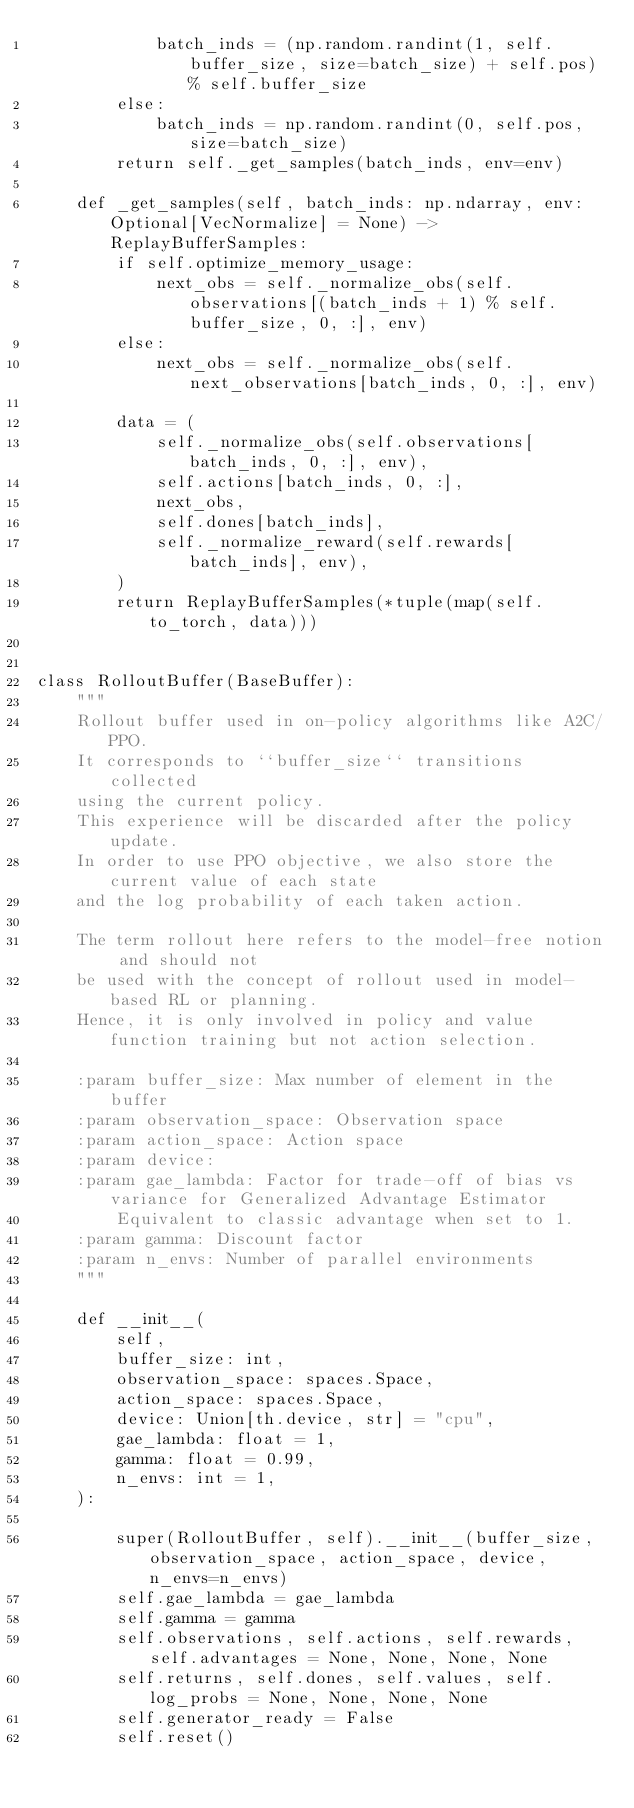<code> <loc_0><loc_0><loc_500><loc_500><_Python_>            batch_inds = (np.random.randint(1, self.buffer_size, size=batch_size) + self.pos) % self.buffer_size
        else:
            batch_inds = np.random.randint(0, self.pos, size=batch_size)
        return self._get_samples(batch_inds, env=env)

    def _get_samples(self, batch_inds: np.ndarray, env: Optional[VecNormalize] = None) -> ReplayBufferSamples:
        if self.optimize_memory_usage:
            next_obs = self._normalize_obs(self.observations[(batch_inds + 1) % self.buffer_size, 0, :], env)
        else:
            next_obs = self._normalize_obs(self.next_observations[batch_inds, 0, :], env)

        data = (
            self._normalize_obs(self.observations[batch_inds, 0, :], env),
            self.actions[batch_inds, 0, :],
            next_obs,
            self.dones[batch_inds],
            self._normalize_reward(self.rewards[batch_inds], env),
        )
        return ReplayBufferSamples(*tuple(map(self.to_torch, data)))


class RolloutBuffer(BaseBuffer):
    """
    Rollout buffer used in on-policy algorithms like A2C/PPO.
    It corresponds to ``buffer_size`` transitions collected
    using the current policy.
    This experience will be discarded after the policy update.
    In order to use PPO objective, we also store the current value of each state
    and the log probability of each taken action.

    The term rollout here refers to the model-free notion and should not
    be used with the concept of rollout used in model-based RL or planning.
    Hence, it is only involved in policy and value function training but not action selection.

    :param buffer_size: Max number of element in the buffer
    :param observation_space: Observation space
    :param action_space: Action space
    :param device:
    :param gae_lambda: Factor for trade-off of bias vs variance for Generalized Advantage Estimator
        Equivalent to classic advantage when set to 1.
    :param gamma: Discount factor
    :param n_envs: Number of parallel environments
    """

    def __init__(
        self,
        buffer_size: int,
        observation_space: spaces.Space,
        action_space: spaces.Space,
        device: Union[th.device, str] = "cpu",
        gae_lambda: float = 1,
        gamma: float = 0.99,
        n_envs: int = 1,
    ):

        super(RolloutBuffer, self).__init__(buffer_size, observation_space, action_space, device, n_envs=n_envs)
        self.gae_lambda = gae_lambda
        self.gamma = gamma
        self.observations, self.actions, self.rewards, self.advantages = None, None, None, None
        self.returns, self.dones, self.values, self.log_probs = None, None, None, None
        self.generator_ready = False
        self.reset()
</code> 